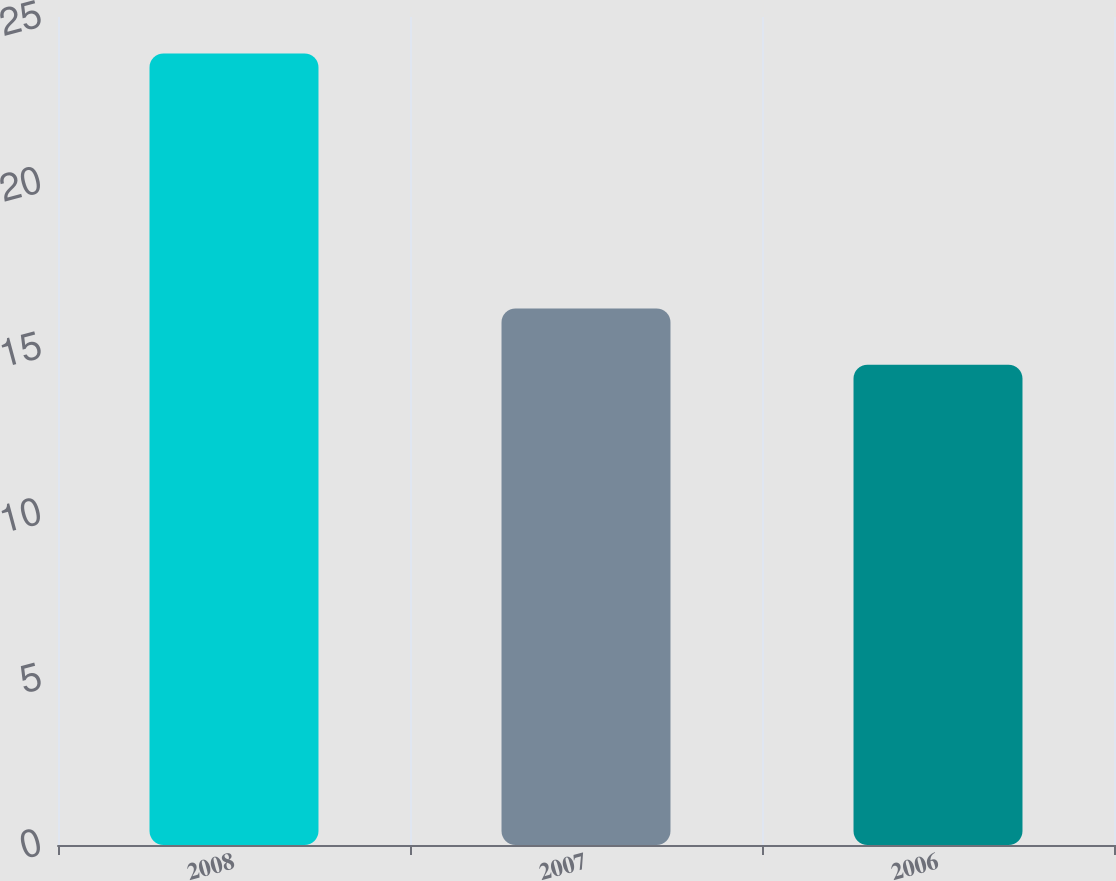<chart> <loc_0><loc_0><loc_500><loc_500><bar_chart><fcel>2008<fcel>2007<fcel>2006<nl><fcel>23.9<fcel>16.2<fcel>14.5<nl></chart> 